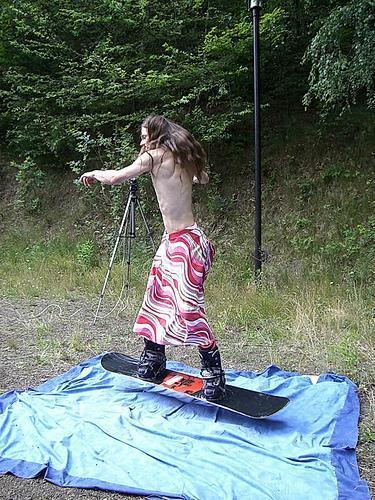How many snowboards are there?
Give a very brief answer. 1. How many people are in the picture?
Give a very brief answer. 1. 